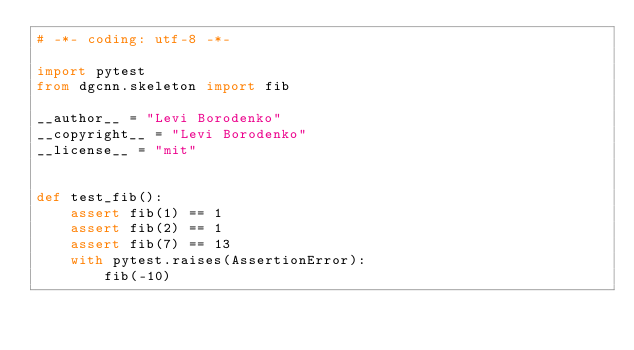Convert code to text. <code><loc_0><loc_0><loc_500><loc_500><_Python_># -*- coding: utf-8 -*-

import pytest
from dgcnn.skeleton import fib

__author__ = "Levi Borodenko"
__copyright__ = "Levi Borodenko"
__license__ = "mit"


def test_fib():
    assert fib(1) == 1
    assert fib(2) == 1
    assert fib(7) == 13
    with pytest.raises(AssertionError):
        fib(-10)
</code> 